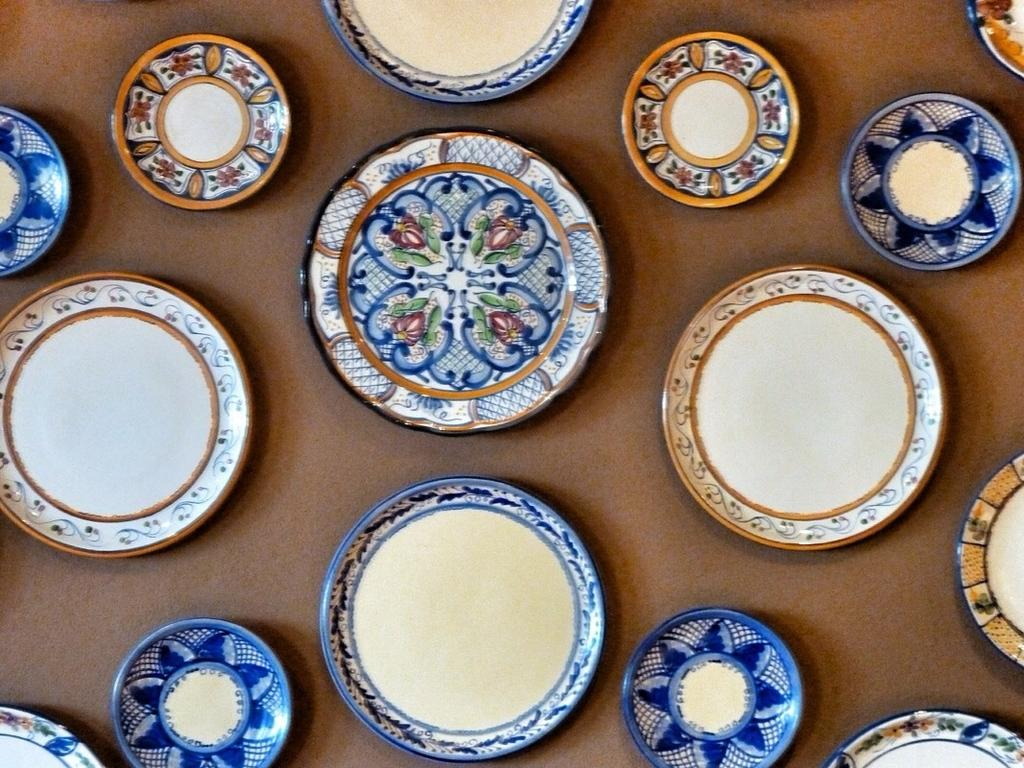What is the main subject of the image? The main subject of the image is many platters. What can be seen beneath the platters? The platters are on a brown surface. Where is the brown surface located in the image? The brown surface is in the foreground of the image. How many needles are scattered in the wilderness in the image? There are no needles or wilderness present in the image; it features many platters on a brown surface. What type of feather can be seen on the platters in the image? There are no feathers present on the platters in the image. 